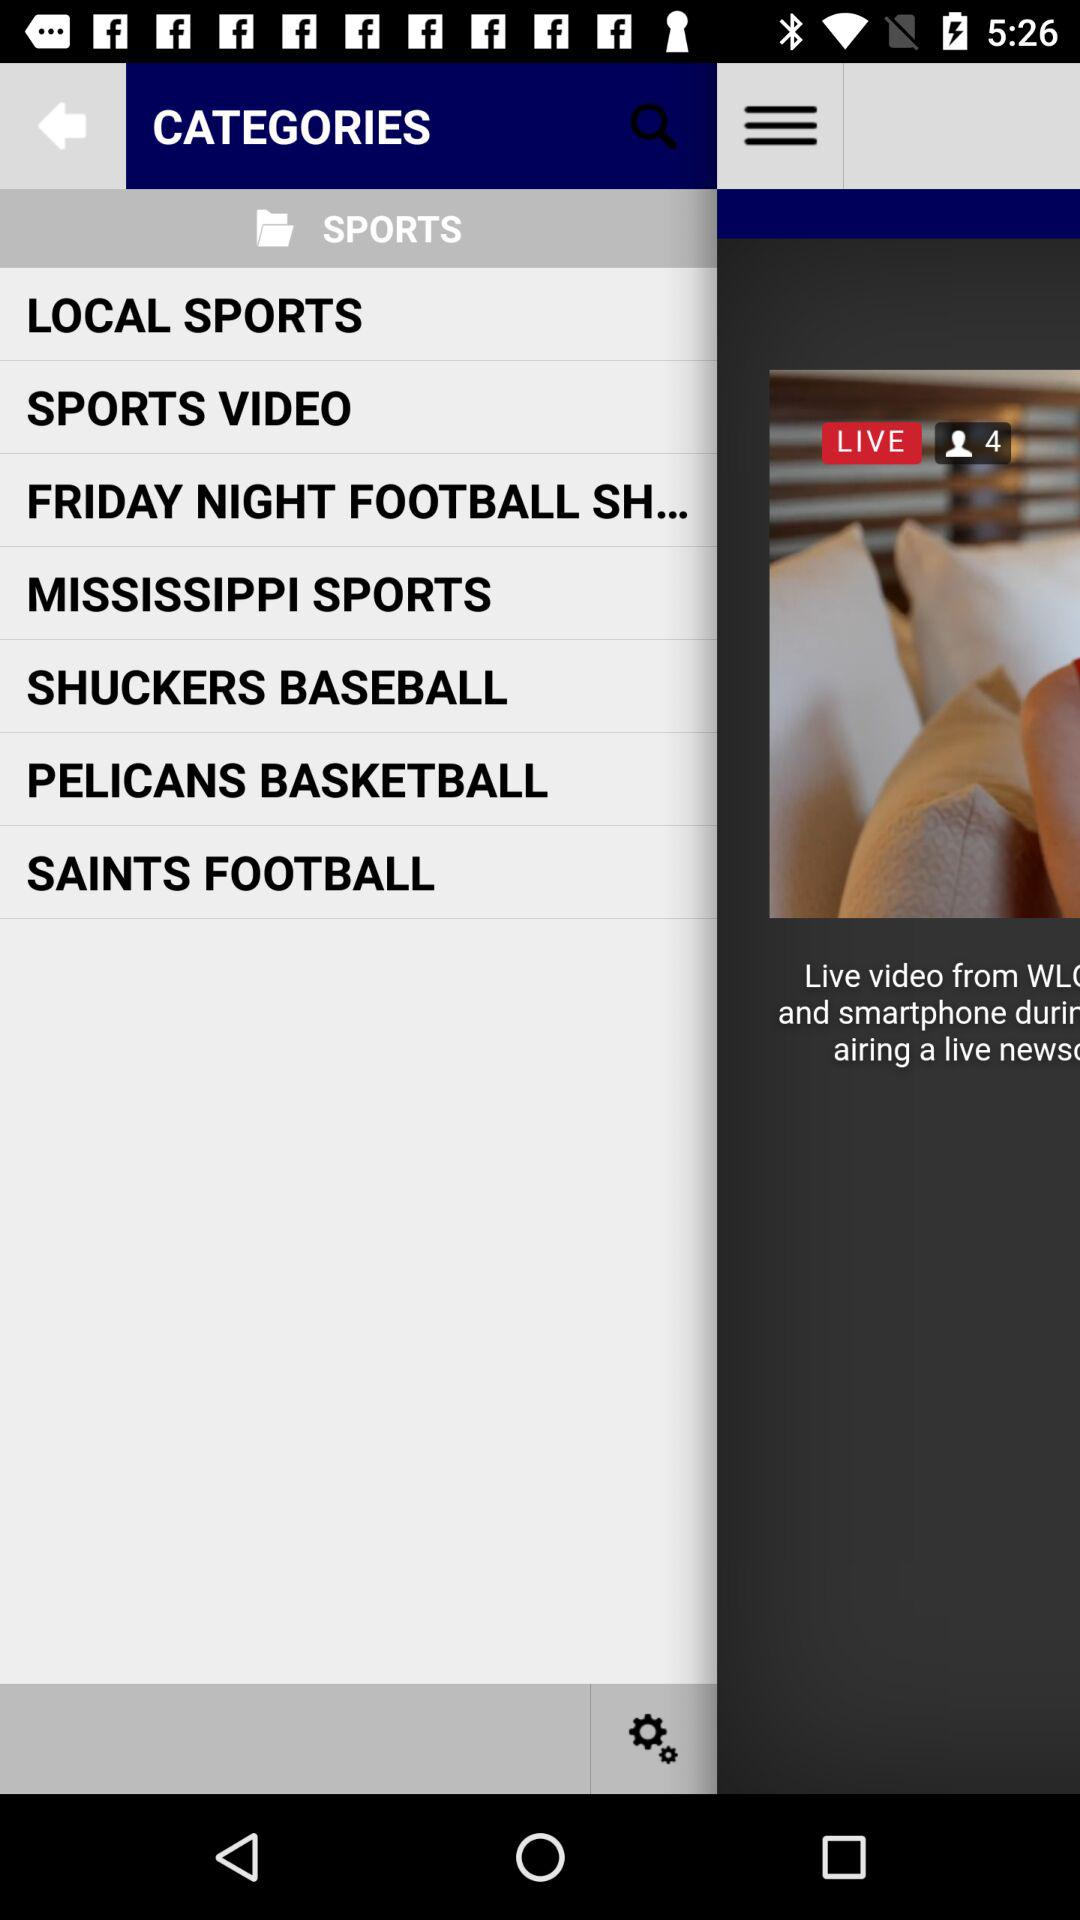How many people are watching the live video? The number of people watching the live video is 4. 